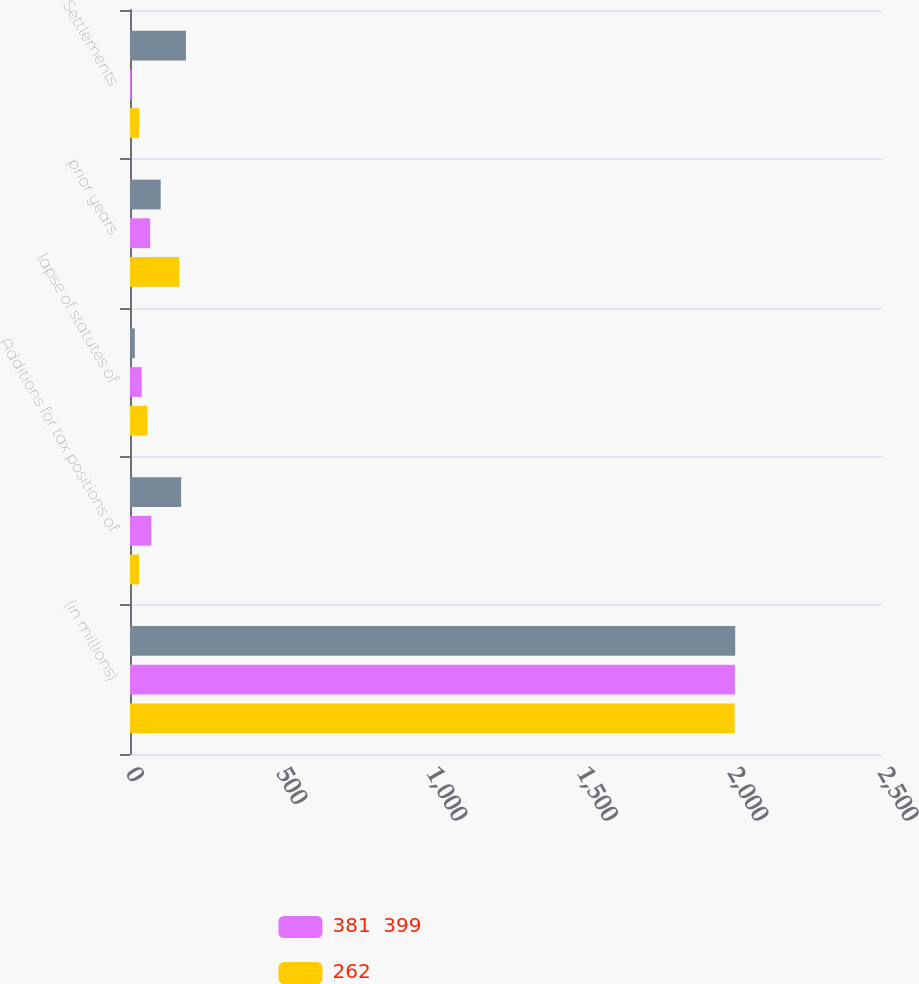<chart> <loc_0><loc_0><loc_500><loc_500><stacked_bar_chart><ecel><fcel>(in millions)<fcel>Additions for tax positions of<fcel>lapse of statutes of<fcel>prior years<fcel>Settlements<nl><fcel>nan<fcel>2012<fcel>170<fcel>16<fcel>102<fcel>186<nl><fcel>381  399<fcel>2011<fcel>71<fcel>39<fcel>67<fcel>5<nl><fcel>262<fcel>2010<fcel>30<fcel>58<fcel>164<fcel>31<nl></chart> 